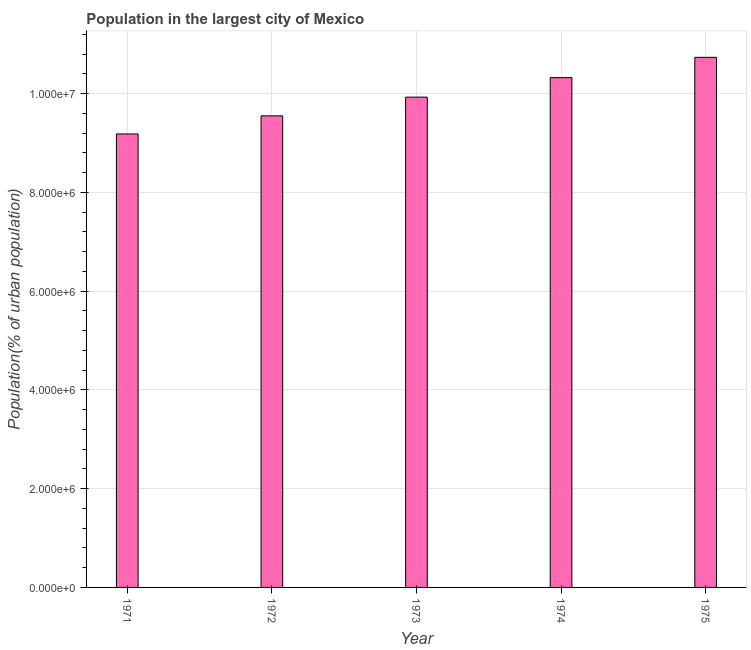What is the title of the graph?
Make the answer very short. Population in the largest city of Mexico. What is the label or title of the Y-axis?
Make the answer very short. Population(% of urban population). What is the population in largest city in 1972?
Offer a very short reply. 9.55e+06. Across all years, what is the maximum population in largest city?
Provide a succinct answer. 1.07e+07. Across all years, what is the minimum population in largest city?
Provide a succinct answer. 9.18e+06. In which year was the population in largest city maximum?
Provide a short and direct response. 1975. In which year was the population in largest city minimum?
Offer a terse response. 1971. What is the sum of the population in largest city?
Offer a very short reply. 4.97e+07. What is the difference between the population in largest city in 1971 and 1972?
Your response must be concise. -3.66e+05. What is the average population in largest city per year?
Provide a short and direct response. 9.94e+06. What is the median population in largest city?
Keep it short and to the point. 9.93e+06. Do a majority of the years between 1975 and 1973 (inclusive) have population in largest city greater than 10000000 %?
Offer a very short reply. Yes. What is the ratio of the population in largest city in 1971 to that in 1972?
Provide a short and direct response. 0.96. Is the population in largest city in 1972 less than that in 1974?
Your response must be concise. Yes. Is the difference between the population in largest city in 1973 and 1975 greater than the difference between any two years?
Provide a short and direct response. No. What is the difference between the highest and the second highest population in largest city?
Your answer should be very brief. 4.11e+05. Is the sum of the population in largest city in 1973 and 1974 greater than the maximum population in largest city across all years?
Keep it short and to the point. Yes. What is the difference between the highest and the lowest population in largest city?
Give a very brief answer. 1.55e+06. In how many years, is the population in largest city greater than the average population in largest city taken over all years?
Offer a terse response. 2. How many bars are there?
Your answer should be compact. 5. What is the difference between two consecutive major ticks on the Y-axis?
Your answer should be compact. 2.00e+06. Are the values on the major ticks of Y-axis written in scientific E-notation?
Provide a succinct answer. Yes. What is the Population(% of urban population) of 1971?
Offer a terse response. 9.18e+06. What is the Population(% of urban population) of 1972?
Provide a short and direct response. 9.55e+06. What is the Population(% of urban population) of 1973?
Your answer should be compact. 9.93e+06. What is the Population(% of urban population) in 1974?
Provide a short and direct response. 1.03e+07. What is the Population(% of urban population) of 1975?
Your answer should be compact. 1.07e+07. What is the difference between the Population(% of urban population) in 1971 and 1972?
Your answer should be very brief. -3.66e+05. What is the difference between the Population(% of urban population) in 1971 and 1973?
Provide a short and direct response. -7.45e+05. What is the difference between the Population(% of urban population) in 1971 and 1974?
Provide a short and direct response. -1.14e+06. What is the difference between the Population(% of urban population) in 1971 and 1975?
Offer a terse response. -1.55e+06. What is the difference between the Population(% of urban population) in 1972 and 1973?
Keep it short and to the point. -3.79e+05. What is the difference between the Population(% of urban population) in 1972 and 1974?
Provide a succinct answer. -7.75e+05. What is the difference between the Population(% of urban population) in 1972 and 1975?
Provide a succinct answer. -1.19e+06. What is the difference between the Population(% of urban population) in 1973 and 1974?
Give a very brief answer. -3.95e+05. What is the difference between the Population(% of urban population) in 1973 and 1975?
Provide a succinct answer. -8.06e+05. What is the difference between the Population(% of urban population) in 1974 and 1975?
Your answer should be compact. -4.11e+05. What is the ratio of the Population(% of urban population) in 1971 to that in 1973?
Ensure brevity in your answer.  0.93. What is the ratio of the Population(% of urban population) in 1971 to that in 1974?
Your response must be concise. 0.89. What is the ratio of the Population(% of urban population) in 1971 to that in 1975?
Give a very brief answer. 0.85. What is the ratio of the Population(% of urban population) in 1972 to that in 1974?
Give a very brief answer. 0.93. What is the ratio of the Population(% of urban population) in 1972 to that in 1975?
Offer a very short reply. 0.89. What is the ratio of the Population(% of urban population) in 1973 to that in 1975?
Ensure brevity in your answer.  0.93. 